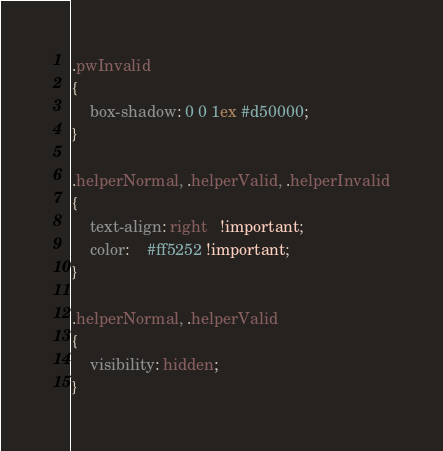<code> <loc_0><loc_0><loc_500><loc_500><_CSS_>
.pwInvalid
{
    box-shadow: 0 0 1ex #d50000;
}

.helperNormal, .helperValid, .helperInvalid
{
    text-align: right   !important;
    color:    #ff5252 !important;
}

.helperNormal, .helperValid
{
    visibility: hidden;
}</code> 